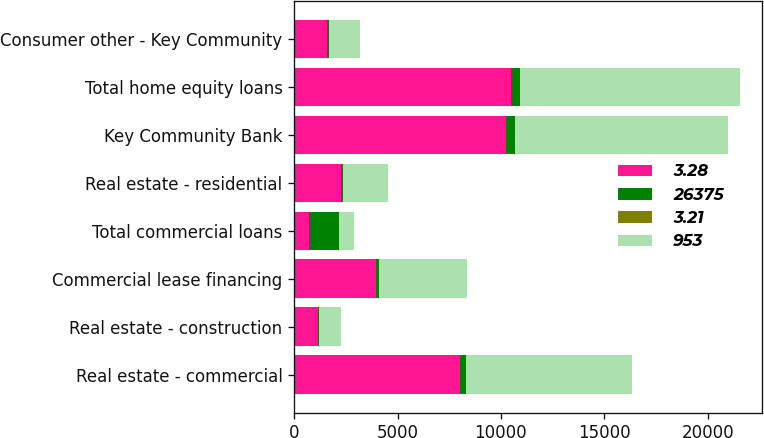<chart> <loc_0><loc_0><loc_500><loc_500><stacked_bar_chart><ecel><fcel>Real estate - commercial<fcel>Real estate - construction<fcel>Commercial lease financing<fcel>Total commercial loans<fcel>Real estate - residential<fcel>Key Community Bank<fcel>Total home equity loans<fcel>Consumer other - Key Community<nl><fcel>3.28<fcel>8020<fcel>1143<fcel>3976<fcel>739.5<fcel>2244<fcel>10266<fcel>10503<fcel>1580<nl><fcel>26375<fcel>295<fcel>43<fcel>143<fcel>1434<fcel>95<fcel>399<fcel>418<fcel>103<nl><fcel>3.21<fcel>3.68<fcel>3.73<fcel>3.6<fcel>3.35<fcel>4.21<fcel>3.89<fcel>3.98<fcel>6.54<nl><fcel>953<fcel>7999<fcel>1061<fcel>4239<fcel>739.5<fcel>2201<fcel>10340<fcel>10639<fcel>1501<nl></chart> 